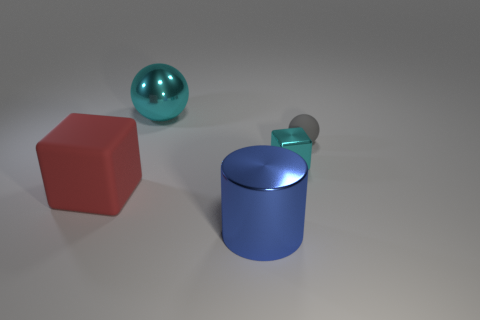What is the big thing left of the big metal object that is behind the blue metallic cylinder made of?
Your answer should be compact. Rubber. How many other objects are the same material as the red thing?
Provide a short and direct response. 1. What is the material of the cyan ball that is the same size as the blue thing?
Offer a terse response. Metal. Is the number of small gray matte objects behind the big cyan thing greater than the number of gray rubber objects that are to the left of the big blue cylinder?
Give a very brief answer. No. Are there any other small things of the same shape as the blue object?
Your answer should be very brief. No. There is a red matte thing that is the same size as the blue thing; what shape is it?
Make the answer very short. Cube. What shape is the cyan metallic object behind the gray object?
Ensure brevity in your answer.  Sphere. Are there fewer cyan shiny cubes that are on the right side of the tiny cyan object than blue objects that are in front of the big blue metal object?
Your answer should be compact. No. Is the size of the cyan cube the same as the rubber thing behind the tiny cyan metallic object?
Provide a short and direct response. Yes. What number of blocks are the same size as the blue cylinder?
Make the answer very short. 1. 